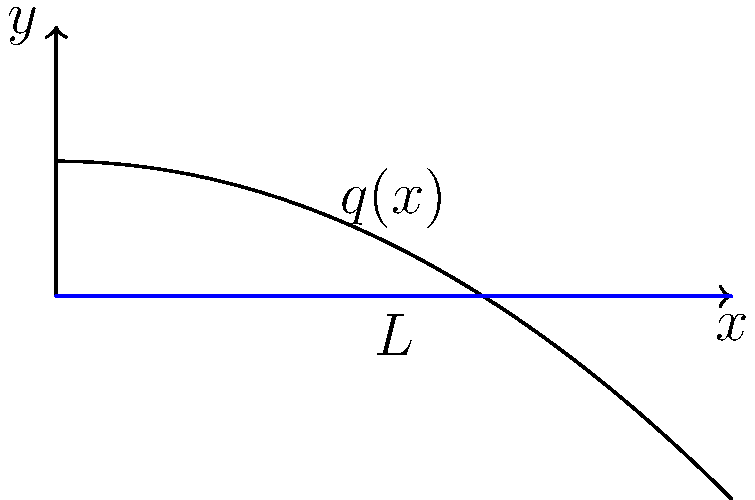A simply supported beam of length $L$ is subjected to a distributed load $q(x) = q_0(1 - \frac{x^2}{L^2})$, where $q_0$ is the maximum load intensity at the center. Given that the beam has a rectangular cross-section with width $b$ and height $h$, determine the maximum bending stress $\sigma_{max}$ in terms of $q_0$, $L$, $b$, and $h$. To solve this problem, we'll follow these steps:

1) First, we need to find the bending moment equation. For a simply supported beam with a distributed load, the bending moment at any point $x$ is given by:

   $$M(x) = \int_0^x (L-x')q(x')dx' - \frac{L}{2}\int_0^L q(x')dx'$$

2) Substitute the given load function:

   $$M(x) = \int_0^x (L-x')q_0(1-\frac{x'^2}{L^2})dx' - \frac{L}{2}\int_0^L q_0(1-\frac{x'^2}{L^2})dx'$$

3) Solve these integrals (this is a complex step, but as a researcher, you're expected to be able to do this):

   $$M(x) = q_0L^2[\frac{x}{L} - \frac{x^2}{2L^2} - \frac{x^3}{3L^3} - \frac{1}{6}]$$

4) The maximum bending moment occurs at the center of the beam ($x = L/2$):

   $$M_{max} = M(L/2) = \frac{5q_0L^2}{96}$$

5) For a rectangular cross-section, the moment of inertia $I$ is:

   $$I = \frac{bh^3}{12}$$

6) The maximum bending stress occurs at the outermost fibers and is given by:

   $$\sigma_{max} = \frac{M_{max}y_{max}}{I} = \frac{M_{max}(h/2)}{I}$$

7) Substitute the expressions for $M_{max}$ and $I$:

   $$\sigma_{max} = \frac{(\frac{5q_0L^2}{96})(\frac{h}{2})}{(\frac{bh^3}{12})}$$

8) Simplify:

   $$\sigma_{max} = \frac{5q_0L^2}{16bh^2}$$

This is the final expression for the maximum bending stress in terms of $q_0$, $L$, $b$, and $h$.
Answer: $\sigma_{max} = \frac{5q_0L^2}{16bh^2}$ 